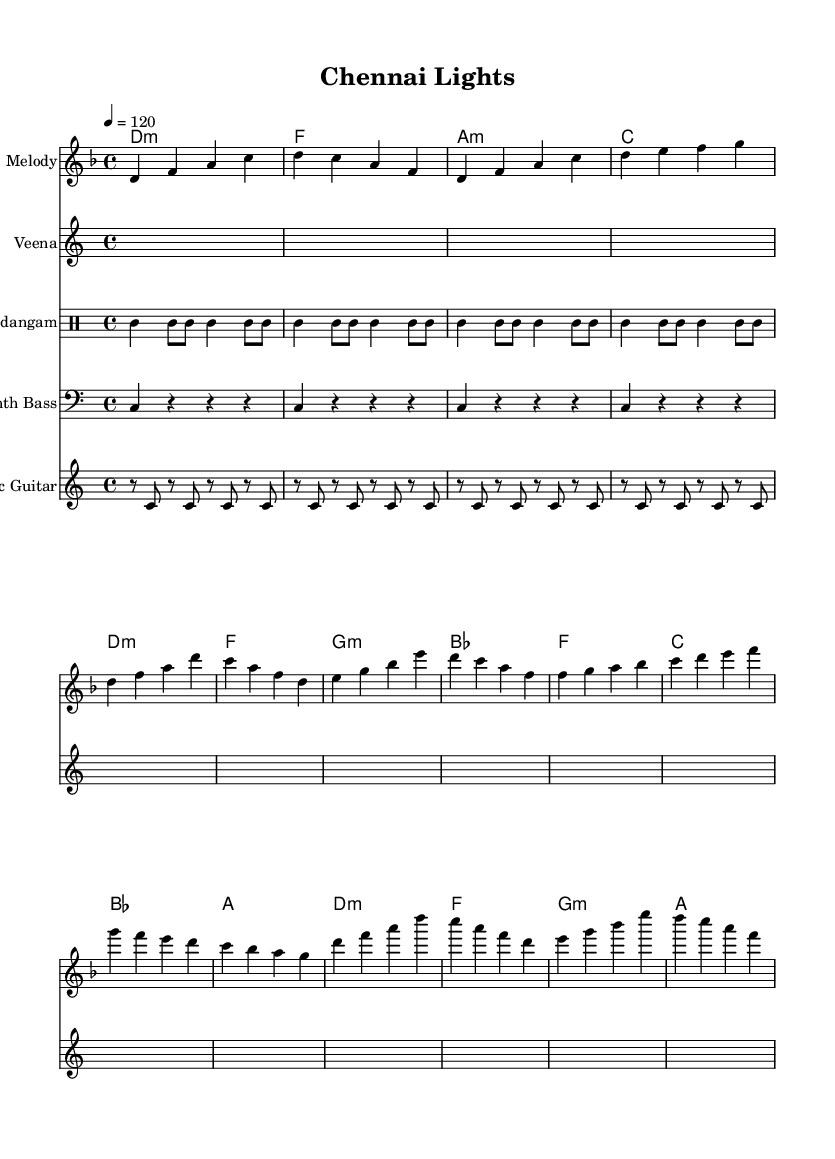What is the key signature of this music? The key signature is D minor, which contains one flat (B flat). It can be identified at the beginning of the staff where the key signature is notated.
Answer: D minor What is the time signature of this music? The time signature is 4/4, which is indicated at the beginning of the music. This means there are four beats per measure, and each quarter note gets one beat.
Answer: 4/4 What is the tempo marking indicated in this music? The tempo marking is indicated as "4 = 120", which suggests that there should be 120 beats per minute. This is a standard practice for tempo indication in sheet music.
Answer: 120 How many measures are in the chorus section? The chorus section consists of four measures, which can be counted in the melody part of the sheet music where the chorus is specifically denoted.
Answer: 4 What instrument is playing the traditional melodies in this piece? The instrument designated for traditional melodies in this sheet music is the Veena, indicated by the staff labeled with its instrument name.
Answer: Veena What type of drum pattern is featured in this composition? The drum pattern used is a Mridangam rhythm, which is a traditional Tamil instrument. This is noted in the drum staff and described with its specific pattern notation.
Answer: Mridangam How many chords are used in the pre-chorus section? The pre-chorus section has four chords, which can be deduced from counting the chord symbols listed in the harmonies section for that part of the music.
Answer: 4 